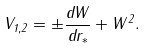<formula> <loc_0><loc_0><loc_500><loc_500>V _ { 1 , 2 } = \pm \frac { d W } { d r _ { * } } + W ^ { 2 } .</formula> 